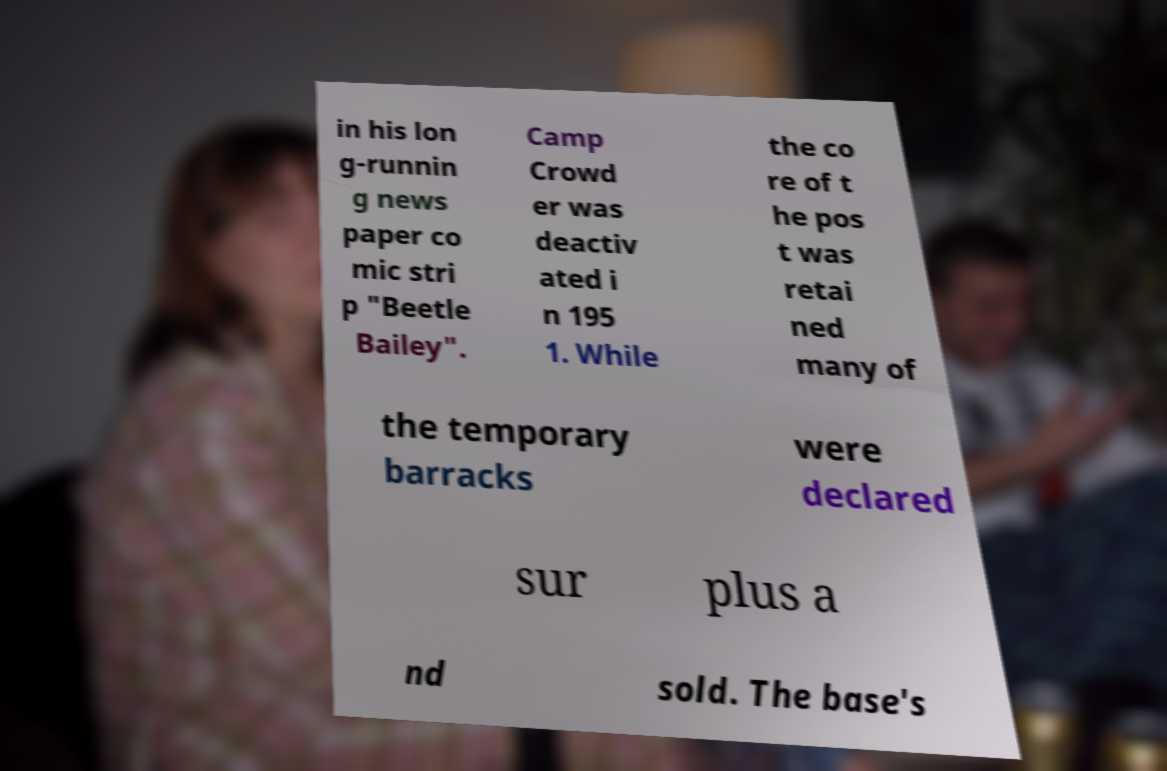For documentation purposes, I need the text within this image transcribed. Could you provide that? in his lon g-runnin g news paper co mic stri p "Beetle Bailey". Camp Crowd er was deactiv ated i n 195 1. While the co re of t he pos t was retai ned many of the temporary barracks were declared sur plus a nd sold. The base's 